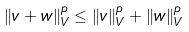<formula> <loc_0><loc_0><loc_500><loc_500>\| v + w \| _ { V } ^ { p } \leq \| v \| _ { V } ^ { p } + \| w \| _ { V } ^ { p }</formula> 